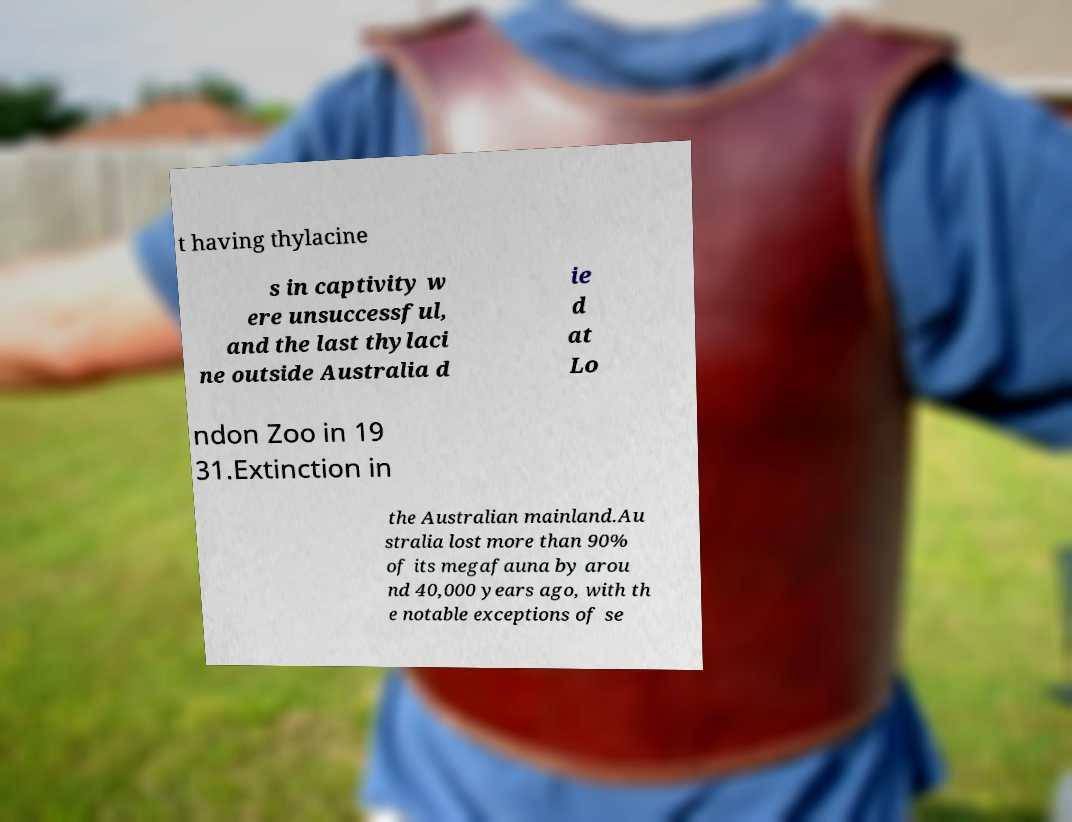What messages or text are displayed in this image? I need them in a readable, typed format. t having thylacine s in captivity w ere unsuccessful, and the last thylaci ne outside Australia d ie d at Lo ndon Zoo in 19 31.Extinction in the Australian mainland.Au stralia lost more than 90% of its megafauna by arou nd 40,000 years ago, with th e notable exceptions of se 